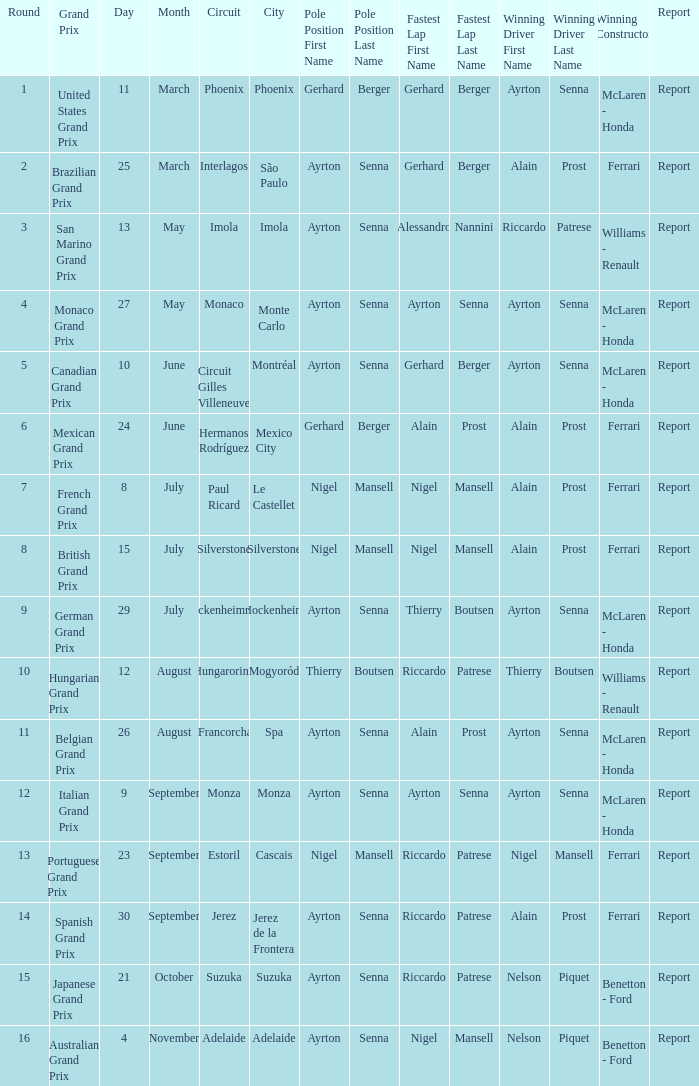What is the date that Ayrton Senna was the drive in Monza? 9 September. 